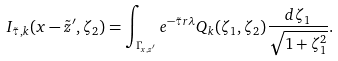<formula> <loc_0><loc_0><loc_500><loc_500>I _ { \tilde { \tau } , k } ( x - \tilde { z } ^ { \prime } , \zeta _ { 2 } ) = \int _ { \Gamma _ { x , z ^ { \prime } } } e ^ { - \tilde { \tau } r \lambda } Q _ { k } ( \zeta _ { 1 } , \zeta _ { 2 } ) \frac { d \zeta _ { 1 } } { \sqrt { 1 + \zeta _ { 1 } ^ { 2 } } } .</formula> 